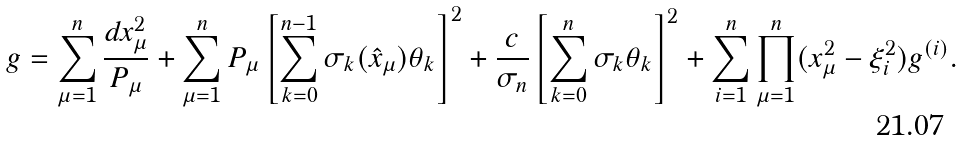<formula> <loc_0><loc_0><loc_500><loc_500>g = \sum _ { \mu = 1 } ^ { n } \frac { d x _ { \mu } ^ { 2 } } { P _ { \mu } } + \sum _ { \mu = 1 } ^ { n } P _ { \mu } \left [ \sum _ { k = 0 } ^ { n - 1 } \sigma _ { k } ( \hat { x } _ { \mu } ) \theta _ { k } \right ] ^ { 2 } + \frac { c } { \sigma _ { n } } \left [ \sum _ { k = 0 } ^ { n } \sigma _ { k } \theta _ { k } \right ] ^ { 2 } + \sum _ { i = 1 } ^ { n } \prod _ { \mu = 1 } ^ { n } ( x _ { \mu } ^ { 2 } - \xi _ { i } ^ { 2 } ) g ^ { ( i ) } .</formula> 